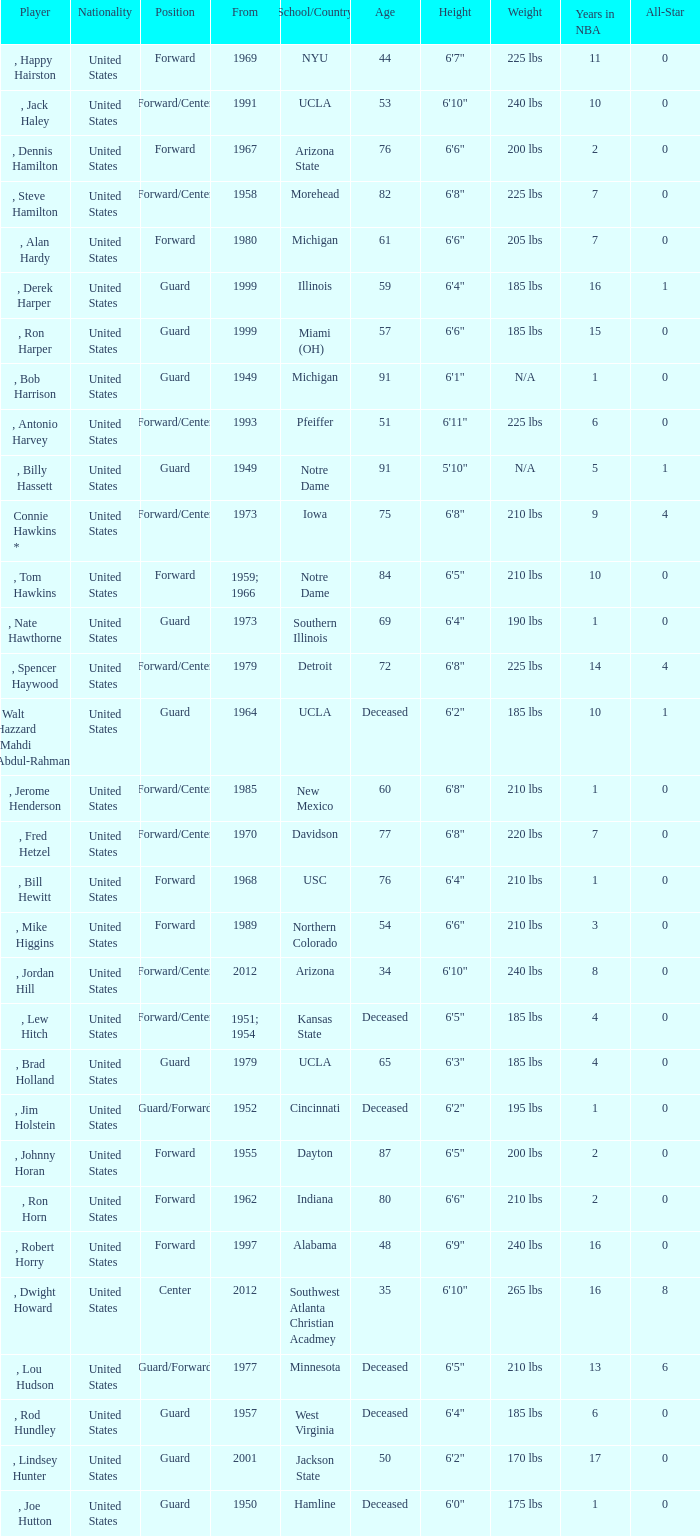Which school has the player that started in 1958? Morehead. 